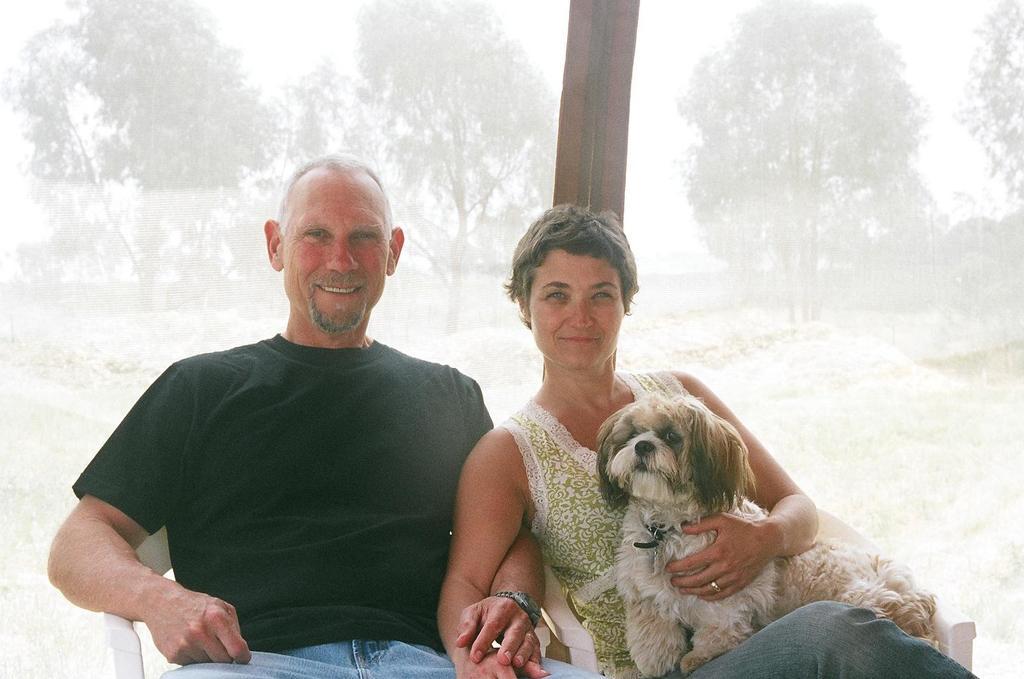Please provide a concise description of this image. In this picture there are two people one among them is a lady and the other is a guy sitting on the chair and the lady is holding the dog. 